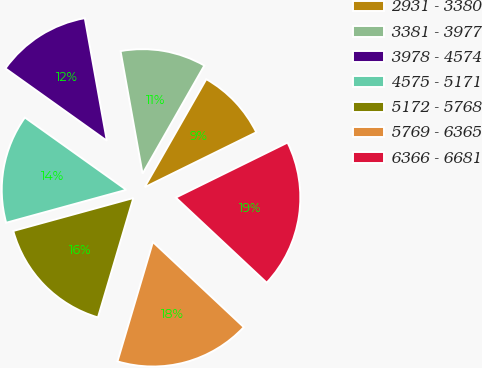Convert chart. <chart><loc_0><loc_0><loc_500><loc_500><pie_chart><fcel>2931 - 3380<fcel>3381 - 3977<fcel>3978 - 4574<fcel>4575 - 5171<fcel>5172 - 5768<fcel>5769 - 6365<fcel>6366 - 6681<nl><fcel>9.46%<fcel>11.09%<fcel>12.31%<fcel>14.12%<fcel>16.15%<fcel>17.61%<fcel>19.26%<nl></chart> 